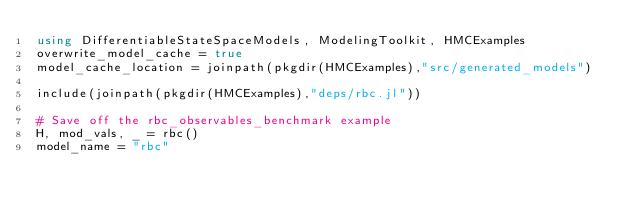<code> <loc_0><loc_0><loc_500><loc_500><_Julia_>using DifferentiableStateSpaceModels, ModelingToolkit, HMCExamples
overwrite_model_cache = true
model_cache_location = joinpath(pkgdir(HMCExamples),"src/generated_models")

include(joinpath(pkgdir(HMCExamples),"deps/rbc.jl"))

# Save off the rbc_observables_benchmark example
H, mod_vals, _ = rbc()
model_name = "rbc"</code> 